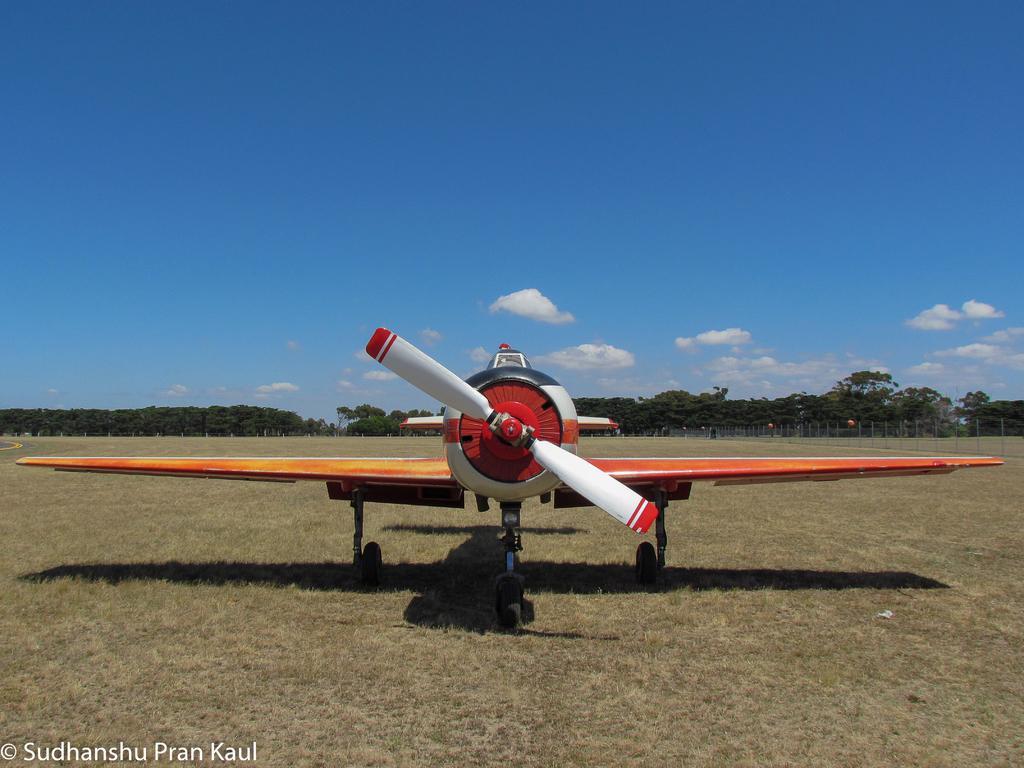Could you give a brief overview of what you see in this image? In the foreground of this image, there is an airplane on the ground. In the background, there are trees, sky and the cloud. 